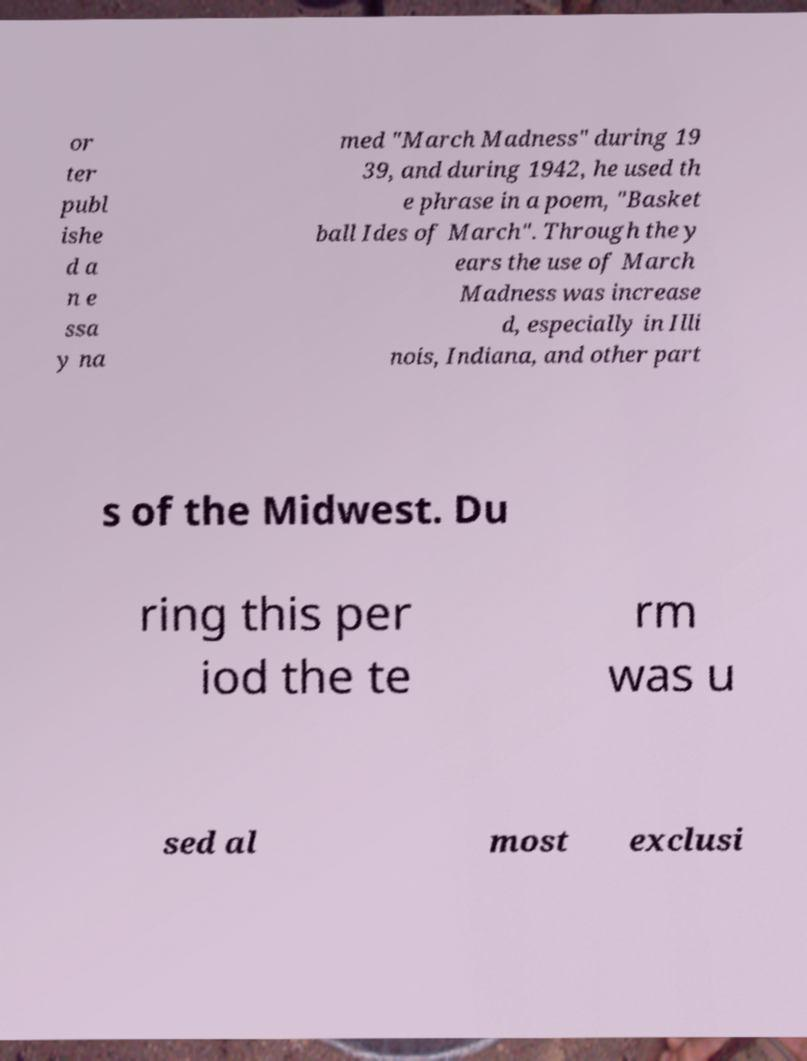Can you read and provide the text displayed in the image?This photo seems to have some interesting text. Can you extract and type it out for me? or ter publ ishe d a n e ssa y na med "March Madness" during 19 39, and during 1942, he used th e phrase in a poem, "Basket ball Ides of March". Through the y ears the use of March Madness was increase d, especially in Illi nois, Indiana, and other part s of the Midwest. Du ring this per iod the te rm was u sed al most exclusi 